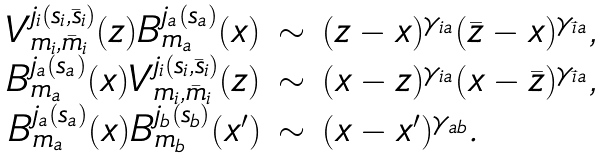Convert formula to latex. <formula><loc_0><loc_0><loc_500><loc_500>\begin{array} { r c l } V ^ { j _ { i } ( s _ { i } , \bar { s } _ { i } ) } _ { m _ { i } , \bar { m } _ { i } } ( z ) B ^ { j _ { a } ( s _ { a } ) } _ { m _ { a } } ( x ) & \sim & ( z - x ) ^ { \gamma _ { i a } } ( \bar { z } - x ) ^ { \gamma _ { \bar { i } a } } , \\ B ^ { j _ { a } ( s _ { a } ) } _ { m _ { a } } ( x ) V ^ { j _ { i } ( s _ { i } , \bar { s } _ { i } ) } _ { m _ { i } , \bar { m } _ { i } } ( z ) & \sim & ( x - z ) ^ { \gamma _ { i a } } ( x - \bar { z } ) ^ { \gamma _ { \bar { i } a } } , \\ B ^ { j _ { a } ( s _ { a } ) } _ { m _ { a } } ( x ) B ^ { j _ { b } ( s _ { b } ) } _ { m _ { b } } ( x ^ { \prime } ) & \sim & ( x - x ^ { \prime } ) ^ { \gamma _ { a b } } . \end{array}</formula> 